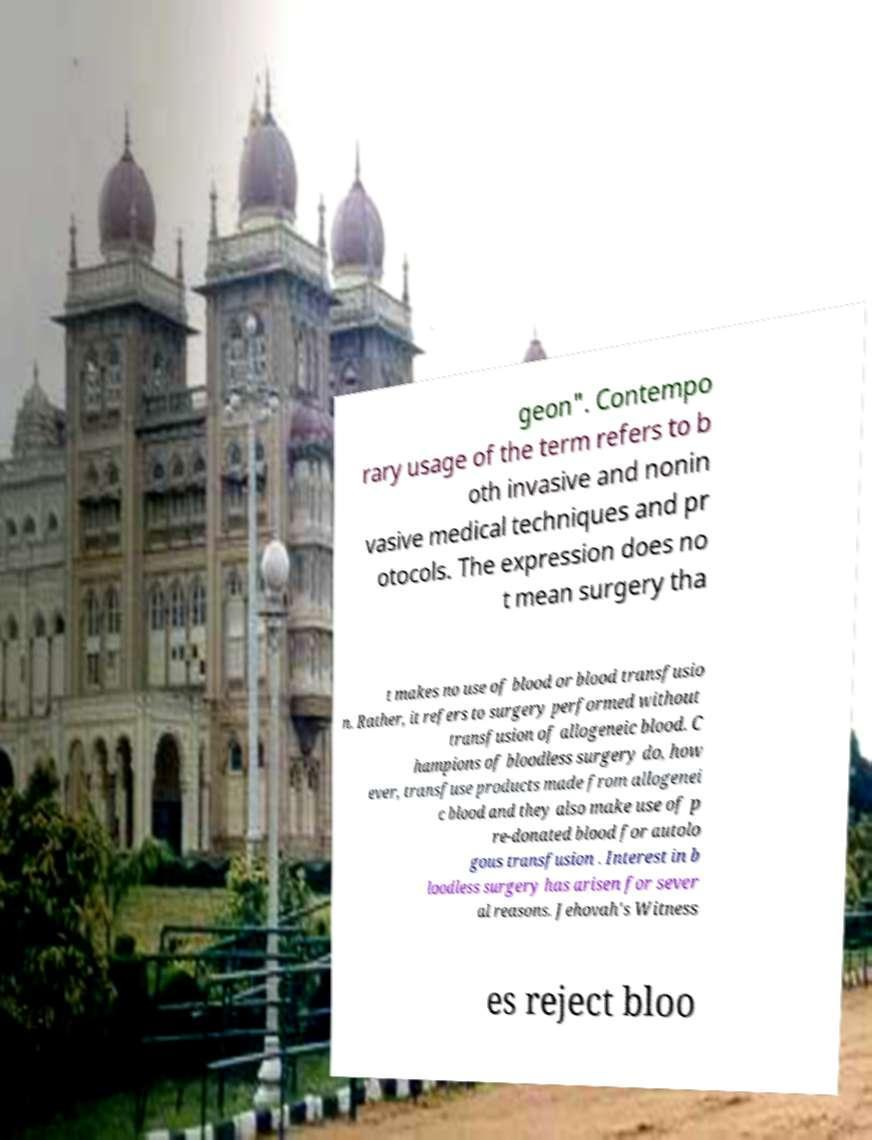Can you accurately transcribe the text from the provided image for me? geon". Contempo rary usage of the term refers to b oth invasive and nonin vasive medical techniques and pr otocols. The expression does no t mean surgery tha t makes no use of blood or blood transfusio n. Rather, it refers to surgery performed without transfusion of allogeneic blood. C hampions of bloodless surgery do, how ever, transfuse products made from allogenei c blood and they also make use of p re-donated blood for autolo gous transfusion . Interest in b loodless surgery has arisen for sever al reasons. Jehovah's Witness es reject bloo 